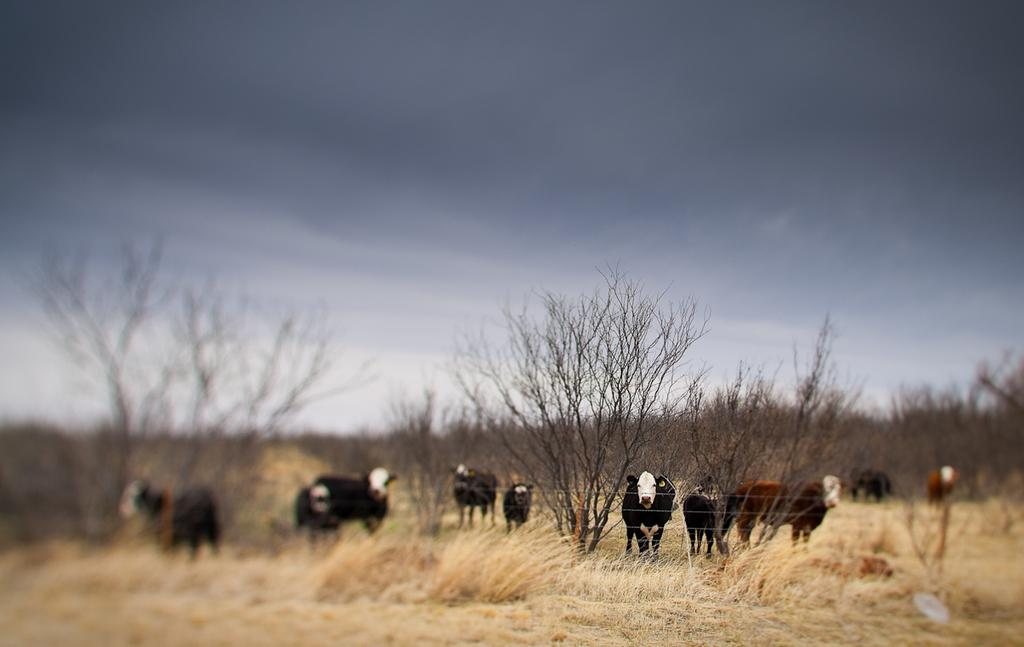What is the main subject of the image? There is a group of animals in the image. What is the position of the animals in the image? The animals are standing on the ground. What can be seen in the background of the image? There is a group of trees and the sky visible in the background of the image. What type of ear is visible on the animals in the image? There is no specific ear mentioned or visible in the image; it only shows a group of animals standing on the ground. 